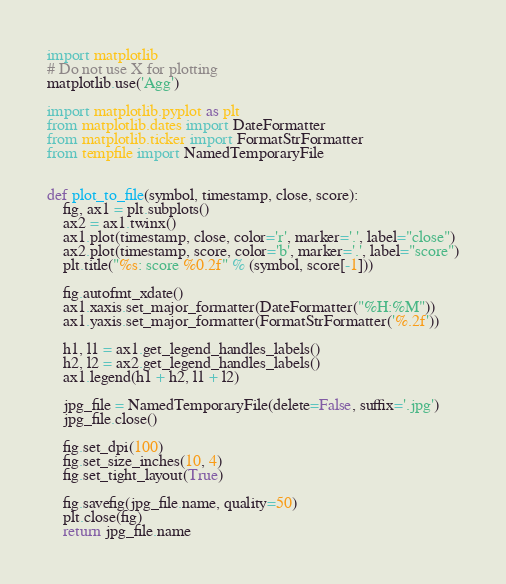Convert code to text. <code><loc_0><loc_0><loc_500><loc_500><_Python_>import matplotlib
# Do not use X for plotting
matplotlib.use('Agg')

import matplotlib.pyplot as plt
from matplotlib.dates import DateFormatter
from matplotlib.ticker import FormatStrFormatter
from tempfile import NamedTemporaryFile


def plot_to_file(symbol, timestamp, close, score):
    fig, ax1 = plt.subplots()
    ax2 = ax1.twinx()
    ax1.plot(timestamp, close, color='r', marker='.', label="close")
    ax2.plot(timestamp, score, color='b', marker='.', label="score")
    plt.title("%s: score %0.2f" % (symbol, score[-1]))

    fig.autofmt_xdate()
    ax1.xaxis.set_major_formatter(DateFormatter("%H:%M"))
    ax1.yaxis.set_major_formatter(FormatStrFormatter('%.2f'))

    h1, l1 = ax1.get_legend_handles_labels()
    h2, l2 = ax2.get_legend_handles_labels()
    ax1.legend(h1 + h2, l1 + l2)

    jpg_file = NamedTemporaryFile(delete=False, suffix='.jpg')
    jpg_file.close()

    fig.set_dpi(100)
    fig.set_size_inches(10, 4)
    fig.set_tight_layout(True)

    fig.savefig(jpg_file.name, quality=50)
    plt.close(fig)
    return jpg_file.name
</code> 